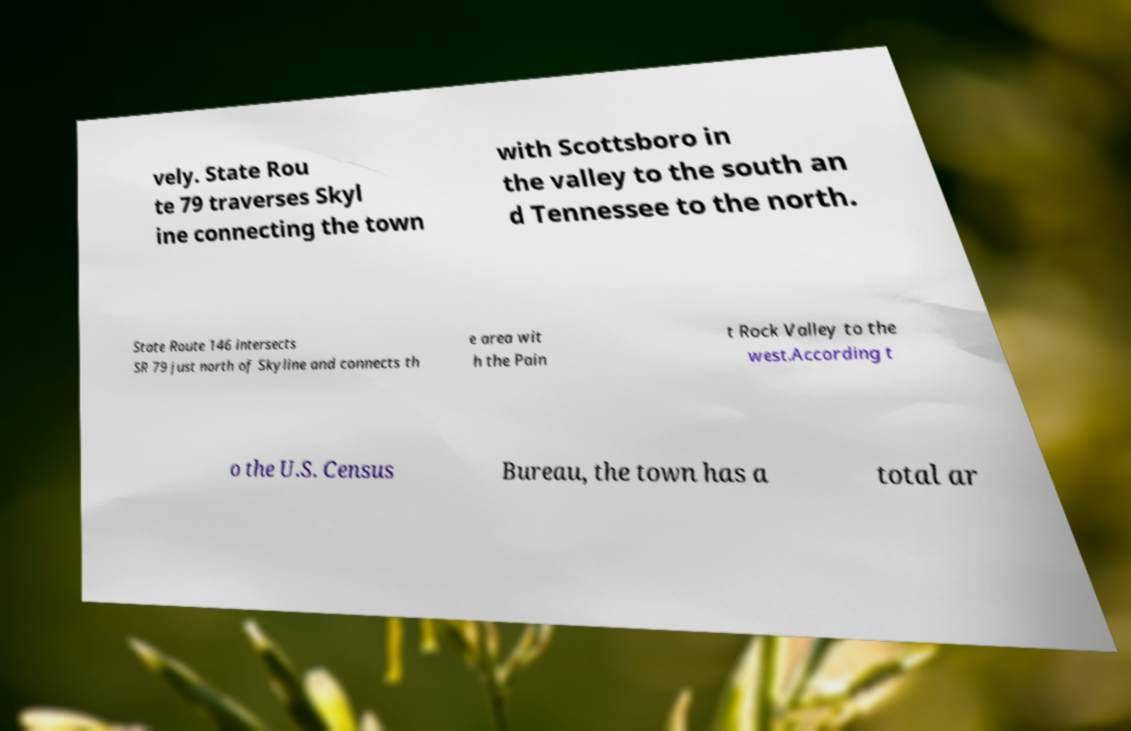For documentation purposes, I need the text within this image transcribed. Could you provide that? vely. State Rou te 79 traverses Skyl ine connecting the town with Scottsboro in the valley to the south an d Tennessee to the north. State Route 146 intersects SR 79 just north of Skyline and connects th e area wit h the Pain t Rock Valley to the west.According t o the U.S. Census Bureau, the town has a total ar 